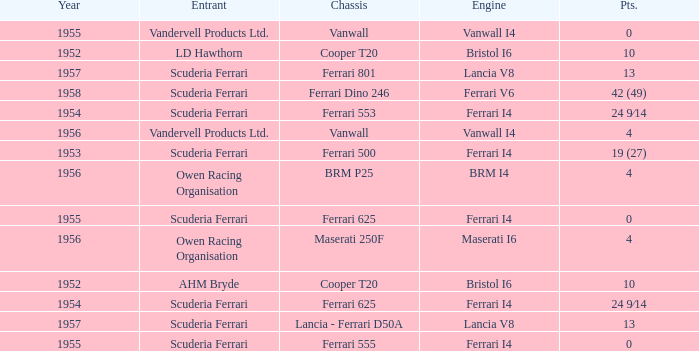Who is the entrant when the year is less than 1953? LD Hawthorn, AHM Bryde. 